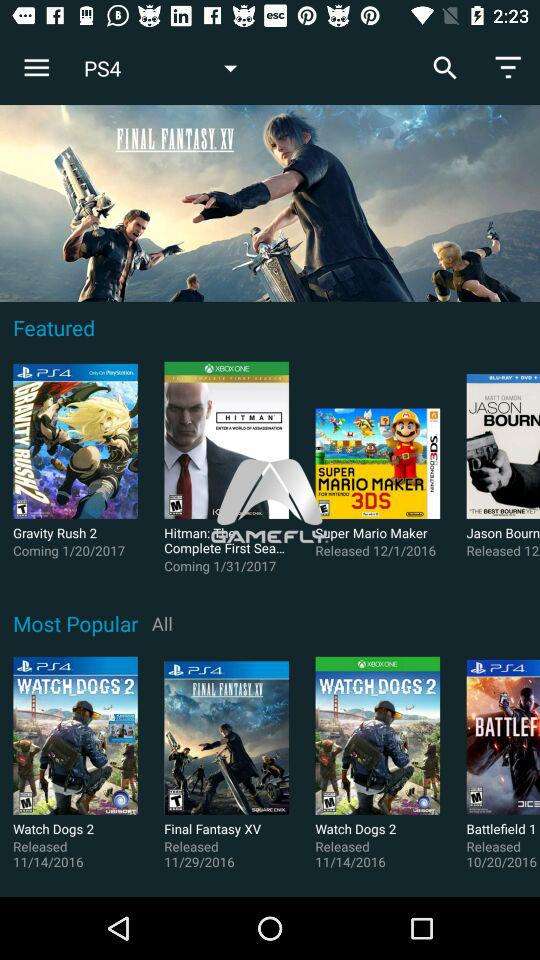On which date is the game "Gravity Rush 2" coming? The game "Gravity Rush 2" is coming on January 20, 2017. 